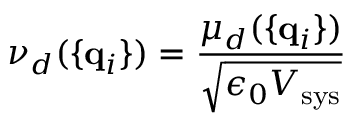<formula> <loc_0><loc_0><loc_500><loc_500>\nu _ { d } ( \{ { q } _ { i } \} ) = { \frac { \mu _ { d } ( \{ { q } _ { i } \} ) } { \sqrt { \epsilon _ { 0 } V _ { s y s } } } }</formula> 